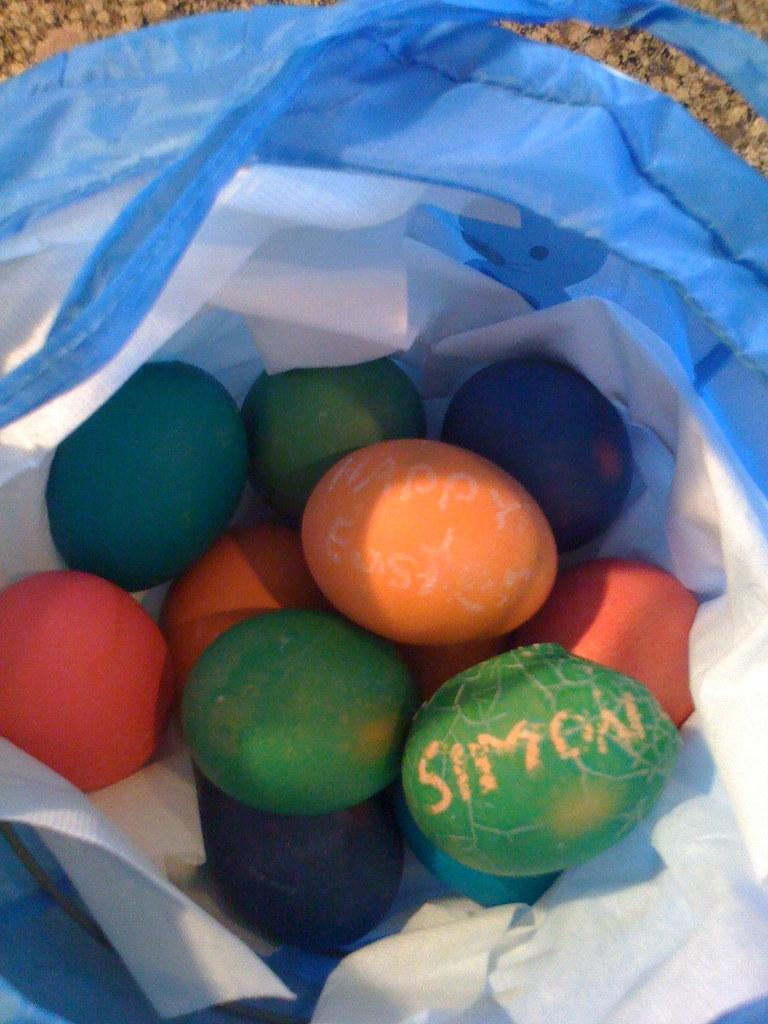What type of items are featured in the image? There are easter eggs in the image. How are the easter eggs being stored or carried? The easter eggs are in a bag. Is there any text present in the image? Yes, there is text visible in the image. What type of war is depicted in the image? There is no war depicted in the image; it features easter eggs in a bag with text visible. Can you tell me how many trains are present in the image? There are no trains present in the image. 